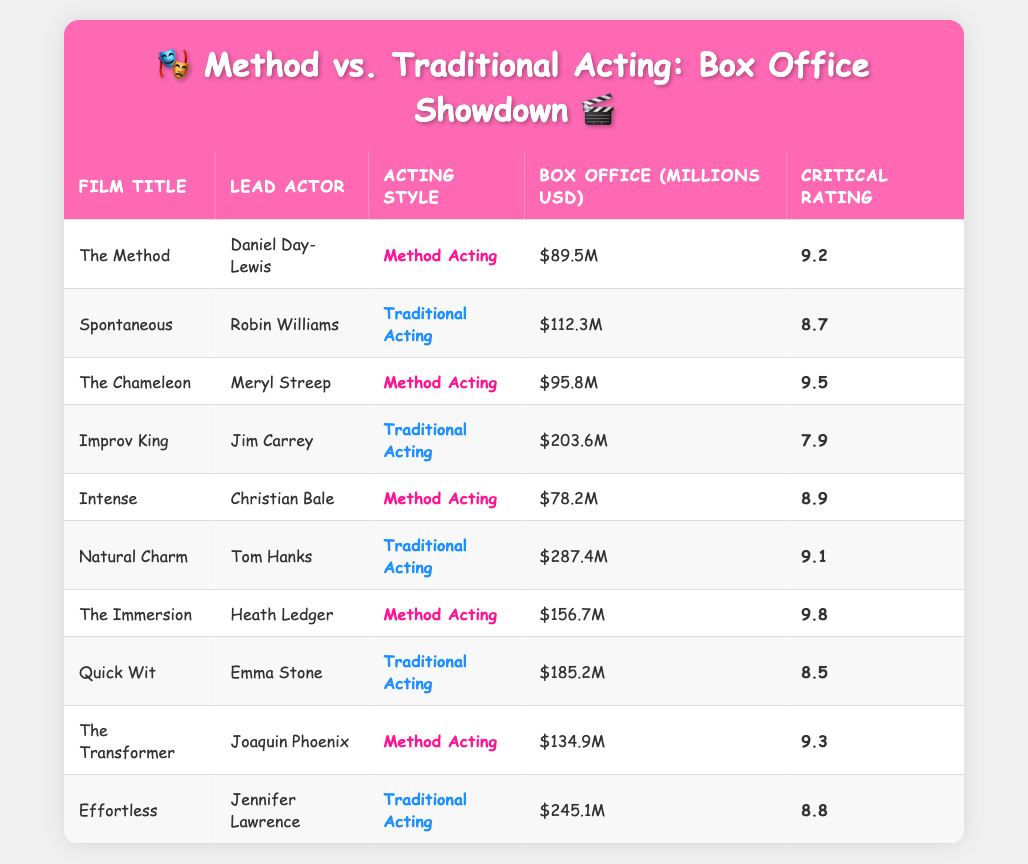What is the highest box office gross for a traditional acting film? The highest box office gross among traditional acting films is in "Natural Charm," which earned 287.4 million USD. I can find this by looking at the "Box Office (Millions USD)" column and identifying the maximum value for rows where the "Acting Style" is "Traditional Acting."
Answer: 287.4 million USD Which film had the highest critical rating among method acting films? The highest critical rating for method acting films is 9.8 for "The Immersion." This can be determined by sorting the "Critical Rating" column for rows labeled "Method Acting" and selecting the highest value.
Answer: 9.8 How many traditional acting films had a box office gross over 200 million USD? There are three traditional acting films that had a box office gross over 200 million USD: "Improv King" (203.6 million USD), "Natural Charm" (287.4 million USD), and "Effortless" (245.1 million USD). I checked the "Box Office (Millions USD)" column for rows with "Traditional Acting" and counted those that exceeded 200 million.
Answer: 3 Which acting style has a higher average box office gross based on the table? To find the average box office gross for each acting style, I will sum the box office gross for both categories and then divide by the number of films in each group. Method Acting: (89.5 + 95.8 + 78.2 + 156.7 + 134.9) / 5 = 111.82 million USD. Traditional Acting: (112.3 + 203.6 + 287.4 + 185.2 + 245.1) / 5 = 206.76 million USD. Traditional acting films have a higher average.
Answer: Traditional Acting Is it true that all method acting films have a critical rating above 8? Yes, all method acting films in the table have critical ratings greater than 8. I can verify this by checking the "Critical Rating" column for each method acting film listed and confirming they all are above 8.
Answer: Yes What is the box office difference between the highest and lowest grossing method acting film? The highest grossing method acting film is "The Immersion" with 156.7 million USD, and the lowest is "Intense" with 78.2 million USD. The difference is 156.7 - 78.2 = 78.5 million USD. I identified the films with the respective highest and lowest gross based on the "Box Office (Millions USD)" column and calculated the difference.
Answer: 78.5 million USD 